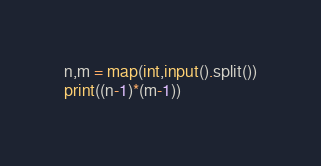Convert code to text. <code><loc_0><loc_0><loc_500><loc_500><_Python_>n,m = map(int,input().split())
print((n-1)*(m-1))</code> 